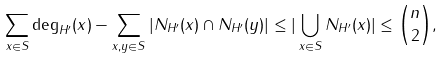<formula> <loc_0><loc_0><loc_500><loc_500>\sum _ { x \in S } \deg _ { H ^ { \prime } } ( x ) - \sum _ { x , y \in S } | N _ { H ^ { \prime } } ( x ) \cap N _ { H ^ { \prime } } ( y ) | \leq | \bigcup _ { x \in S } N _ { H ^ { \prime } } ( x ) | \leq \binom { n } { 2 } ,</formula> 